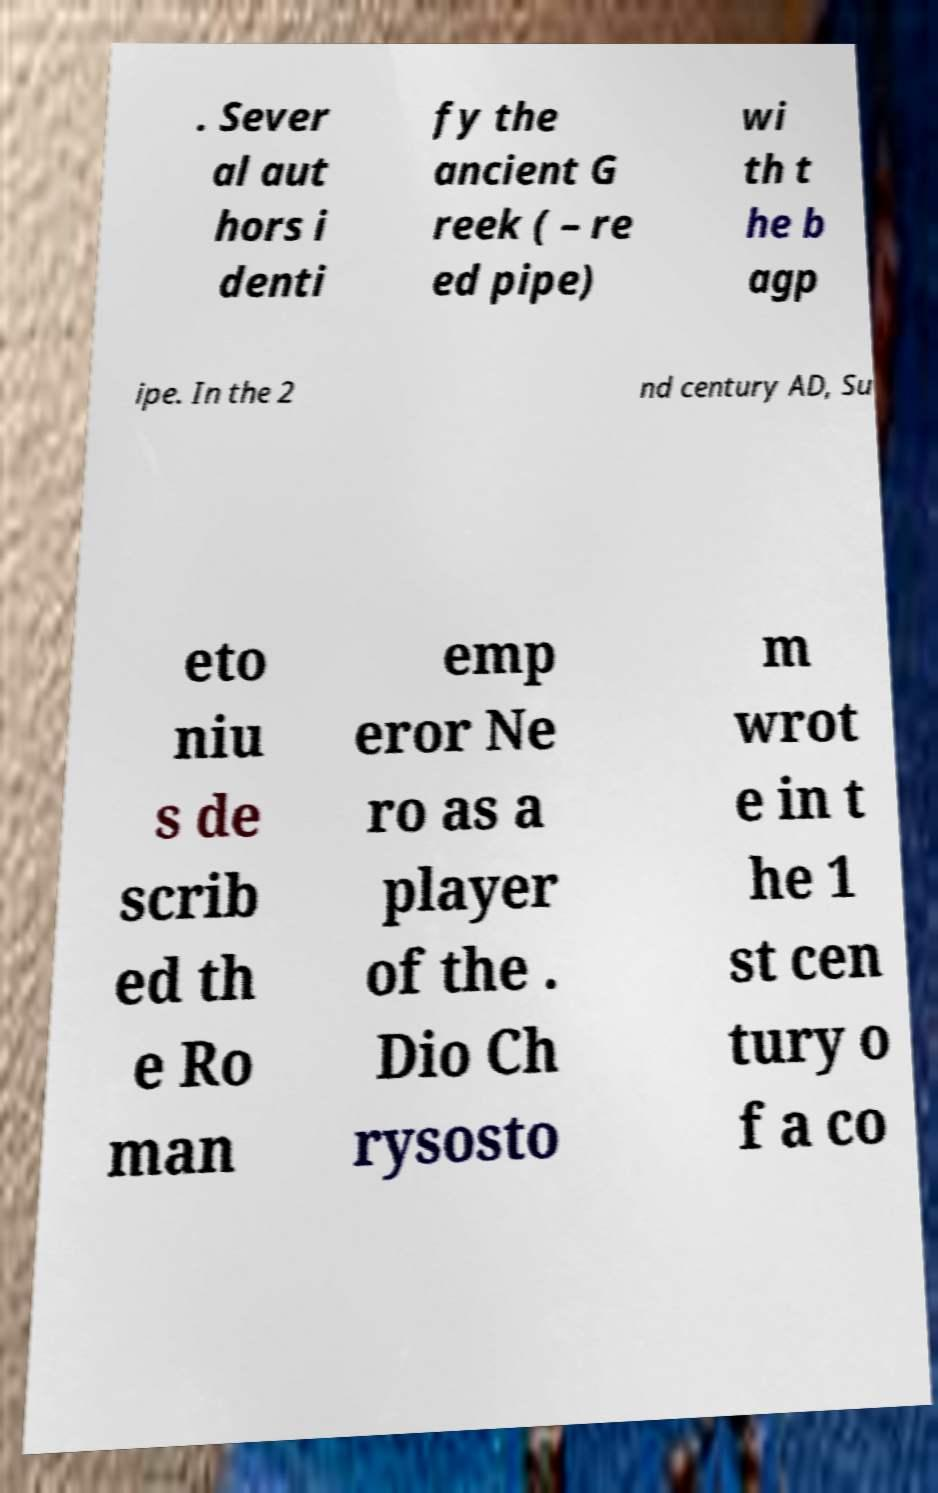Could you extract and type out the text from this image? . Sever al aut hors i denti fy the ancient G reek ( – re ed pipe) wi th t he b agp ipe. In the 2 nd century AD, Su eto niu s de scrib ed th e Ro man emp eror Ne ro as a player of the . Dio Ch rysosto m wrot e in t he 1 st cen tury o f a co 